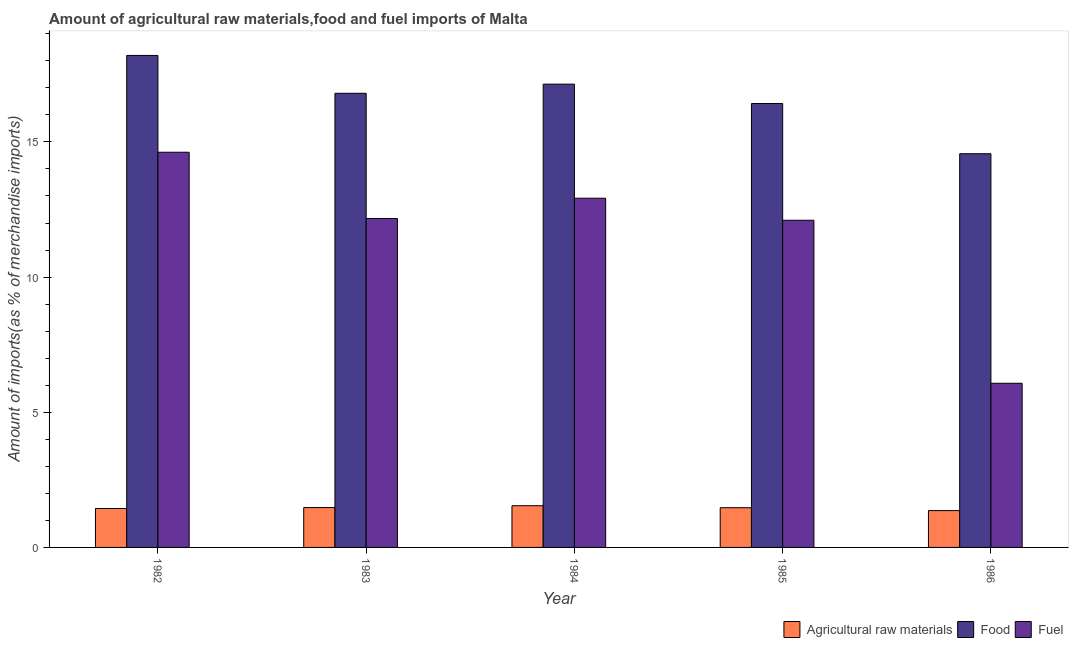Are the number of bars per tick equal to the number of legend labels?
Keep it short and to the point. Yes. Are the number of bars on each tick of the X-axis equal?
Offer a terse response. Yes. How many bars are there on the 4th tick from the left?
Make the answer very short. 3. What is the percentage of raw materials imports in 1985?
Provide a succinct answer. 1.47. Across all years, what is the maximum percentage of fuel imports?
Provide a succinct answer. 14.62. Across all years, what is the minimum percentage of fuel imports?
Provide a short and direct response. 6.07. In which year was the percentage of fuel imports maximum?
Offer a very short reply. 1982. What is the total percentage of fuel imports in the graph?
Your response must be concise. 57.88. What is the difference between the percentage of fuel imports in 1983 and that in 1985?
Provide a short and direct response. 0.07. What is the difference between the percentage of food imports in 1983 and the percentage of fuel imports in 1984?
Keep it short and to the point. -0.34. What is the average percentage of raw materials imports per year?
Keep it short and to the point. 1.46. In how many years, is the percentage of fuel imports greater than 4 %?
Make the answer very short. 5. What is the ratio of the percentage of fuel imports in 1983 to that in 1984?
Provide a succinct answer. 0.94. Is the difference between the percentage of raw materials imports in 1982 and 1984 greater than the difference between the percentage of food imports in 1982 and 1984?
Your answer should be very brief. No. What is the difference between the highest and the second highest percentage of raw materials imports?
Give a very brief answer. 0.07. What is the difference between the highest and the lowest percentage of raw materials imports?
Ensure brevity in your answer.  0.18. In how many years, is the percentage of food imports greater than the average percentage of food imports taken over all years?
Your answer should be very brief. 3. Is the sum of the percentage of raw materials imports in 1984 and 1986 greater than the maximum percentage of food imports across all years?
Provide a short and direct response. Yes. What does the 2nd bar from the left in 1982 represents?
Offer a very short reply. Food. What does the 1st bar from the right in 1985 represents?
Ensure brevity in your answer.  Fuel. How many bars are there?
Keep it short and to the point. 15. How many years are there in the graph?
Provide a succinct answer. 5. Does the graph contain grids?
Your response must be concise. No. How many legend labels are there?
Make the answer very short. 3. What is the title of the graph?
Make the answer very short. Amount of agricultural raw materials,food and fuel imports of Malta. What is the label or title of the X-axis?
Your answer should be very brief. Year. What is the label or title of the Y-axis?
Offer a very short reply. Amount of imports(as % of merchandise imports). What is the Amount of imports(as % of merchandise imports) in Agricultural raw materials in 1982?
Provide a succinct answer. 1.44. What is the Amount of imports(as % of merchandise imports) in Food in 1982?
Offer a terse response. 18.2. What is the Amount of imports(as % of merchandise imports) in Fuel in 1982?
Your answer should be compact. 14.62. What is the Amount of imports(as % of merchandise imports) of Agricultural raw materials in 1983?
Provide a short and direct response. 1.48. What is the Amount of imports(as % of merchandise imports) of Food in 1983?
Keep it short and to the point. 16.8. What is the Amount of imports(as % of merchandise imports) in Fuel in 1983?
Your answer should be very brief. 12.17. What is the Amount of imports(as % of merchandise imports) of Agricultural raw materials in 1984?
Give a very brief answer. 1.54. What is the Amount of imports(as % of merchandise imports) in Food in 1984?
Your answer should be very brief. 17.14. What is the Amount of imports(as % of merchandise imports) in Fuel in 1984?
Ensure brevity in your answer.  12.92. What is the Amount of imports(as % of merchandise imports) of Agricultural raw materials in 1985?
Give a very brief answer. 1.47. What is the Amount of imports(as % of merchandise imports) in Food in 1985?
Provide a succinct answer. 16.42. What is the Amount of imports(as % of merchandise imports) in Fuel in 1985?
Offer a terse response. 12.1. What is the Amount of imports(as % of merchandise imports) of Agricultural raw materials in 1986?
Give a very brief answer. 1.36. What is the Amount of imports(as % of merchandise imports) of Food in 1986?
Give a very brief answer. 14.56. What is the Amount of imports(as % of merchandise imports) of Fuel in 1986?
Make the answer very short. 6.07. Across all years, what is the maximum Amount of imports(as % of merchandise imports) in Agricultural raw materials?
Make the answer very short. 1.54. Across all years, what is the maximum Amount of imports(as % of merchandise imports) of Food?
Offer a terse response. 18.2. Across all years, what is the maximum Amount of imports(as % of merchandise imports) of Fuel?
Keep it short and to the point. 14.62. Across all years, what is the minimum Amount of imports(as % of merchandise imports) in Agricultural raw materials?
Offer a very short reply. 1.36. Across all years, what is the minimum Amount of imports(as % of merchandise imports) of Food?
Provide a succinct answer. 14.56. Across all years, what is the minimum Amount of imports(as % of merchandise imports) in Fuel?
Give a very brief answer. 6.07. What is the total Amount of imports(as % of merchandise imports) in Agricultural raw materials in the graph?
Keep it short and to the point. 7.29. What is the total Amount of imports(as % of merchandise imports) of Food in the graph?
Your answer should be very brief. 83.12. What is the total Amount of imports(as % of merchandise imports) of Fuel in the graph?
Provide a short and direct response. 57.88. What is the difference between the Amount of imports(as % of merchandise imports) in Agricultural raw materials in 1982 and that in 1983?
Provide a succinct answer. -0.03. What is the difference between the Amount of imports(as % of merchandise imports) of Food in 1982 and that in 1983?
Provide a short and direct response. 1.4. What is the difference between the Amount of imports(as % of merchandise imports) in Fuel in 1982 and that in 1983?
Your response must be concise. 2.45. What is the difference between the Amount of imports(as % of merchandise imports) in Agricultural raw materials in 1982 and that in 1984?
Your answer should be compact. -0.1. What is the difference between the Amount of imports(as % of merchandise imports) of Food in 1982 and that in 1984?
Offer a very short reply. 1.06. What is the difference between the Amount of imports(as % of merchandise imports) of Fuel in 1982 and that in 1984?
Offer a terse response. 1.7. What is the difference between the Amount of imports(as % of merchandise imports) of Agricultural raw materials in 1982 and that in 1985?
Provide a succinct answer. -0.03. What is the difference between the Amount of imports(as % of merchandise imports) of Food in 1982 and that in 1985?
Keep it short and to the point. 1.78. What is the difference between the Amount of imports(as % of merchandise imports) of Fuel in 1982 and that in 1985?
Your answer should be compact. 2.52. What is the difference between the Amount of imports(as % of merchandise imports) of Agricultural raw materials in 1982 and that in 1986?
Your answer should be very brief. 0.08. What is the difference between the Amount of imports(as % of merchandise imports) in Food in 1982 and that in 1986?
Give a very brief answer. 3.64. What is the difference between the Amount of imports(as % of merchandise imports) in Fuel in 1982 and that in 1986?
Ensure brevity in your answer.  8.55. What is the difference between the Amount of imports(as % of merchandise imports) of Agricultural raw materials in 1983 and that in 1984?
Your answer should be compact. -0.07. What is the difference between the Amount of imports(as % of merchandise imports) in Food in 1983 and that in 1984?
Offer a very short reply. -0.34. What is the difference between the Amount of imports(as % of merchandise imports) of Fuel in 1983 and that in 1984?
Your answer should be very brief. -0.75. What is the difference between the Amount of imports(as % of merchandise imports) of Agricultural raw materials in 1983 and that in 1985?
Offer a terse response. 0.01. What is the difference between the Amount of imports(as % of merchandise imports) of Food in 1983 and that in 1985?
Offer a very short reply. 0.38. What is the difference between the Amount of imports(as % of merchandise imports) of Fuel in 1983 and that in 1985?
Keep it short and to the point. 0.07. What is the difference between the Amount of imports(as % of merchandise imports) of Agricultural raw materials in 1983 and that in 1986?
Your answer should be compact. 0.11. What is the difference between the Amount of imports(as % of merchandise imports) of Food in 1983 and that in 1986?
Give a very brief answer. 2.24. What is the difference between the Amount of imports(as % of merchandise imports) of Fuel in 1983 and that in 1986?
Your answer should be very brief. 6.1. What is the difference between the Amount of imports(as % of merchandise imports) of Agricultural raw materials in 1984 and that in 1985?
Ensure brevity in your answer.  0.07. What is the difference between the Amount of imports(as % of merchandise imports) of Food in 1984 and that in 1985?
Offer a very short reply. 0.72. What is the difference between the Amount of imports(as % of merchandise imports) of Fuel in 1984 and that in 1985?
Provide a succinct answer. 0.82. What is the difference between the Amount of imports(as % of merchandise imports) of Agricultural raw materials in 1984 and that in 1986?
Keep it short and to the point. 0.18. What is the difference between the Amount of imports(as % of merchandise imports) of Food in 1984 and that in 1986?
Offer a very short reply. 2.57. What is the difference between the Amount of imports(as % of merchandise imports) in Fuel in 1984 and that in 1986?
Provide a short and direct response. 6.85. What is the difference between the Amount of imports(as % of merchandise imports) in Agricultural raw materials in 1985 and that in 1986?
Your response must be concise. 0.11. What is the difference between the Amount of imports(as % of merchandise imports) of Food in 1985 and that in 1986?
Offer a very short reply. 1.86. What is the difference between the Amount of imports(as % of merchandise imports) in Fuel in 1985 and that in 1986?
Give a very brief answer. 6.03. What is the difference between the Amount of imports(as % of merchandise imports) of Agricultural raw materials in 1982 and the Amount of imports(as % of merchandise imports) of Food in 1983?
Your answer should be compact. -15.36. What is the difference between the Amount of imports(as % of merchandise imports) in Agricultural raw materials in 1982 and the Amount of imports(as % of merchandise imports) in Fuel in 1983?
Your answer should be very brief. -10.73. What is the difference between the Amount of imports(as % of merchandise imports) in Food in 1982 and the Amount of imports(as % of merchandise imports) in Fuel in 1983?
Your response must be concise. 6.03. What is the difference between the Amount of imports(as % of merchandise imports) in Agricultural raw materials in 1982 and the Amount of imports(as % of merchandise imports) in Food in 1984?
Your response must be concise. -15.7. What is the difference between the Amount of imports(as % of merchandise imports) of Agricultural raw materials in 1982 and the Amount of imports(as % of merchandise imports) of Fuel in 1984?
Your answer should be very brief. -11.48. What is the difference between the Amount of imports(as % of merchandise imports) of Food in 1982 and the Amount of imports(as % of merchandise imports) of Fuel in 1984?
Make the answer very short. 5.28. What is the difference between the Amount of imports(as % of merchandise imports) in Agricultural raw materials in 1982 and the Amount of imports(as % of merchandise imports) in Food in 1985?
Keep it short and to the point. -14.98. What is the difference between the Amount of imports(as % of merchandise imports) of Agricultural raw materials in 1982 and the Amount of imports(as % of merchandise imports) of Fuel in 1985?
Provide a succinct answer. -10.66. What is the difference between the Amount of imports(as % of merchandise imports) of Food in 1982 and the Amount of imports(as % of merchandise imports) of Fuel in 1985?
Make the answer very short. 6.1. What is the difference between the Amount of imports(as % of merchandise imports) of Agricultural raw materials in 1982 and the Amount of imports(as % of merchandise imports) of Food in 1986?
Your answer should be very brief. -13.12. What is the difference between the Amount of imports(as % of merchandise imports) in Agricultural raw materials in 1982 and the Amount of imports(as % of merchandise imports) in Fuel in 1986?
Give a very brief answer. -4.63. What is the difference between the Amount of imports(as % of merchandise imports) of Food in 1982 and the Amount of imports(as % of merchandise imports) of Fuel in 1986?
Ensure brevity in your answer.  12.13. What is the difference between the Amount of imports(as % of merchandise imports) of Agricultural raw materials in 1983 and the Amount of imports(as % of merchandise imports) of Food in 1984?
Provide a succinct answer. -15.66. What is the difference between the Amount of imports(as % of merchandise imports) of Agricultural raw materials in 1983 and the Amount of imports(as % of merchandise imports) of Fuel in 1984?
Offer a terse response. -11.44. What is the difference between the Amount of imports(as % of merchandise imports) of Food in 1983 and the Amount of imports(as % of merchandise imports) of Fuel in 1984?
Make the answer very short. 3.88. What is the difference between the Amount of imports(as % of merchandise imports) of Agricultural raw materials in 1983 and the Amount of imports(as % of merchandise imports) of Food in 1985?
Offer a terse response. -14.95. What is the difference between the Amount of imports(as % of merchandise imports) in Agricultural raw materials in 1983 and the Amount of imports(as % of merchandise imports) in Fuel in 1985?
Offer a terse response. -10.63. What is the difference between the Amount of imports(as % of merchandise imports) in Food in 1983 and the Amount of imports(as % of merchandise imports) in Fuel in 1985?
Offer a terse response. 4.7. What is the difference between the Amount of imports(as % of merchandise imports) in Agricultural raw materials in 1983 and the Amount of imports(as % of merchandise imports) in Food in 1986?
Offer a very short reply. -13.09. What is the difference between the Amount of imports(as % of merchandise imports) in Agricultural raw materials in 1983 and the Amount of imports(as % of merchandise imports) in Fuel in 1986?
Ensure brevity in your answer.  -4.6. What is the difference between the Amount of imports(as % of merchandise imports) of Food in 1983 and the Amount of imports(as % of merchandise imports) of Fuel in 1986?
Provide a short and direct response. 10.73. What is the difference between the Amount of imports(as % of merchandise imports) of Agricultural raw materials in 1984 and the Amount of imports(as % of merchandise imports) of Food in 1985?
Your answer should be compact. -14.88. What is the difference between the Amount of imports(as % of merchandise imports) in Agricultural raw materials in 1984 and the Amount of imports(as % of merchandise imports) in Fuel in 1985?
Ensure brevity in your answer.  -10.56. What is the difference between the Amount of imports(as % of merchandise imports) in Food in 1984 and the Amount of imports(as % of merchandise imports) in Fuel in 1985?
Offer a very short reply. 5.03. What is the difference between the Amount of imports(as % of merchandise imports) of Agricultural raw materials in 1984 and the Amount of imports(as % of merchandise imports) of Food in 1986?
Your answer should be very brief. -13.02. What is the difference between the Amount of imports(as % of merchandise imports) in Agricultural raw materials in 1984 and the Amount of imports(as % of merchandise imports) in Fuel in 1986?
Your answer should be very brief. -4.53. What is the difference between the Amount of imports(as % of merchandise imports) of Food in 1984 and the Amount of imports(as % of merchandise imports) of Fuel in 1986?
Your answer should be compact. 11.06. What is the difference between the Amount of imports(as % of merchandise imports) in Agricultural raw materials in 1985 and the Amount of imports(as % of merchandise imports) in Food in 1986?
Your response must be concise. -13.09. What is the difference between the Amount of imports(as % of merchandise imports) in Agricultural raw materials in 1985 and the Amount of imports(as % of merchandise imports) in Fuel in 1986?
Provide a succinct answer. -4.6. What is the difference between the Amount of imports(as % of merchandise imports) in Food in 1985 and the Amount of imports(as % of merchandise imports) in Fuel in 1986?
Keep it short and to the point. 10.35. What is the average Amount of imports(as % of merchandise imports) in Agricultural raw materials per year?
Ensure brevity in your answer.  1.46. What is the average Amount of imports(as % of merchandise imports) in Food per year?
Provide a short and direct response. 16.62. What is the average Amount of imports(as % of merchandise imports) in Fuel per year?
Provide a short and direct response. 11.58. In the year 1982, what is the difference between the Amount of imports(as % of merchandise imports) of Agricultural raw materials and Amount of imports(as % of merchandise imports) of Food?
Give a very brief answer. -16.76. In the year 1982, what is the difference between the Amount of imports(as % of merchandise imports) in Agricultural raw materials and Amount of imports(as % of merchandise imports) in Fuel?
Your response must be concise. -13.18. In the year 1982, what is the difference between the Amount of imports(as % of merchandise imports) of Food and Amount of imports(as % of merchandise imports) of Fuel?
Your answer should be very brief. 3.58. In the year 1983, what is the difference between the Amount of imports(as % of merchandise imports) in Agricultural raw materials and Amount of imports(as % of merchandise imports) in Food?
Keep it short and to the point. -15.32. In the year 1983, what is the difference between the Amount of imports(as % of merchandise imports) in Agricultural raw materials and Amount of imports(as % of merchandise imports) in Fuel?
Your answer should be very brief. -10.69. In the year 1983, what is the difference between the Amount of imports(as % of merchandise imports) in Food and Amount of imports(as % of merchandise imports) in Fuel?
Ensure brevity in your answer.  4.63. In the year 1984, what is the difference between the Amount of imports(as % of merchandise imports) in Agricultural raw materials and Amount of imports(as % of merchandise imports) in Food?
Keep it short and to the point. -15.59. In the year 1984, what is the difference between the Amount of imports(as % of merchandise imports) of Agricultural raw materials and Amount of imports(as % of merchandise imports) of Fuel?
Your answer should be very brief. -11.37. In the year 1984, what is the difference between the Amount of imports(as % of merchandise imports) of Food and Amount of imports(as % of merchandise imports) of Fuel?
Give a very brief answer. 4.22. In the year 1985, what is the difference between the Amount of imports(as % of merchandise imports) in Agricultural raw materials and Amount of imports(as % of merchandise imports) in Food?
Keep it short and to the point. -14.95. In the year 1985, what is the difference between the Amount of imports(as % of merchandise imports) in Agricultural raw materials and Amount of imports(as % of merchandise imports) in Fuel?
Ensure brevity in your answer.  -10.63. In the year 1985, what is the difference between the Amount of imports(as % of merchandise imports) in Food and Amount of imports(as % of merchandise imports) in Fuel?
Your response must be concise. 4.32. In the year 1986, what is the difference between the Amount of imports(as % of merchandise imports) of Agricultural raw materials and Amount of imports(as % of merchandise imports) of Food?
Provide a succinct answer. -13.2. In the year 1986, what is the difference between the Amount of imports(as % of merchandise imports) in Agricultural raw materials and Amount of imports(as % of merchandise imports) in Fuel?
Offer a terse response. -4.71. In the year 1986, what is the difference between the Amount of imports(as % of merchandise imports) in Food and Amount of imports(as % of merchandise imports) in Fuel?
Your answer should be compact. 8.49. What is the ratio of the Amount of imports(as % of merchandise imports) of Agricultural raw materials in 1982 to that in 1983?
Your response must be concise. 0.98. What is the ratio of the Amount of imports(as % of merchandise imports) of Food in 1982 to that in 1983?
Make the answer very short. 1.08. What is the ratio of the Amount of imports(as % of merchandise imports) of Fuel in 1982 to that in 1983?
Make the answer very short. 1.2. What is the ratio of the Amount of imports(as % of merchandise imports) in Agricultural raw materials in 1982 to that in 1984?
Make the answer very short. 0.93. What is the ratio of the Amount of imports(as % of merchandise imports) of Food in 1982 to that in 1984?
Provide a short and direct response. 1.06. What is the ratio of the Amount of imports(as % of merchandise imports) in Fuel in 1982 to that in 1984?
Provide a short and direct response. 1.13. What is the ratio of the Amount of imports(as % of merchandise imports) in Agricultural raw materials in 1982 to that in 1985?
Provide a succinct answer. 0.98. What is the ratio of the Amount of imports(as % of merchandise imports) in Food in 1982 to that in 1985?
Your answer should be very brief. 1.11. What is the ratio of the Amount of imports(as % of merchandise imports) of Fuel in 1982 to that in 1985?
Give a very brief answer. 1.21. What is the ratio of the Amount of imports(as % of merchandise imports) of Agricultural raw materials in 1982 to that in 1986?
Keep it short and to the point. 1.06. What is the ratio of the Amount of imports(as % of merchandise imports) in Food in 1982 to that in 1986?
Your answer should be compact. 1.25. What is the ratio of the Amount of imports(as % of merchandise imports) in Fuel in 1982 to that in 1986?
Offer a very short reply. 2.41. What is the ratio of the Amount of imports(as % of merchandise imports) of Agricultural raw materials in 1983 to that in 1984?
Your response must be concise. 0.96. What is the ratio of the Amount of imports(as % of merchandise imports) of Food in 1983 to that in 1984?
Make the answer very short. 0.98. What is the ratio of the Amount of imports(as % of merchandise imports) in Fuel in 1983 to that in 1984?
Make the answer very short. 0.94. What is the ratio of the Amount of imports(as % of merchandise imports) of Fuel in 1983 to that in 1985?
Keep it short and to the point. 1.01. What is the ratio of the Amount of imports(as % of merchandise imports) in Agricultural raw materials in 1983 to that in 1986?
Provide a short and direct response. 1.08. What is the ratio of the Amount of imports(as % of merchandise imports) of Food in 1983 to that in 1986?
Provide a succinct answer. 1.15. What is the ratio of the Amount of imports(as % of merchandise imports) in Fuel in 1983 to that in 1986?
Give a very brief answer. 2. What is the ratio of the Amount of imports(as % of merchandise imports) in Agricultural raw materials in 1984 to that in 1985?
Provide a succinct answer. 1.05. What is the ratio of the Amount of imports(as % of merchandise imports) in Food in 1984 to that in 1985?
Give a very brief answer. 1.04. What is the ratio of the Amount of imports(as % of merchandise imports) in Fuel in 1984 to that in 1985?
Give a very brief answer. 1.07. What is the ratio of the Amount of imports(as % of merchandise imports) of Agricultural raw materials in 1984 to that in 1986?
Give a very brief answer. 1.13. What is the ratio of the Amount of imports(as % of merchandise imports) in Food in 1984 to that in 1986?
Make the answer very short. 1.18. What is the ratio of the Amount of imports(as % of merchandise imports) in Fuel in 1984 to that in 1986?
Give a very brief answer. 2.13. What is the ratio of the Amount of imports(as % of merchandise imports) of Agricultural raw materials in 1985 to that in 1986?
Keep it short and to the point. 1.08. What is the ratio of the Amount of imports(as % of merchandise imports) of Food in 1985 to that in 1986?
Offer a very short reply. 1.13. What is the ratio of the Amount of imports(as % of merchandise imports) of Fuel in 1985 to that in 1986?
Give a very brief answer. 1.99. What is the difference between the highest and the second highest Amount of imports(as % of merchandise imports) in Agricultural raw materials?
Your answer should be compact. 0.07. What is the difference between the highest and the second highest Amount of imports(as % of merchandise imports) of Food?
Provide a succinct answer. 1.06. What is the difference between the highest and the second highest Amount of imports(as % of merchandise imports) in Fuel?
Offer a terse response. 1.7. What is the difference between the highest and the lowest Amount of imports(as % of merchandise imports) in Agricultural raw materials?
Offer a terse response. 0.18. What is the difference between the highest and the lowest Amount of imports(as % of merchandise imports) in Food?
Your answer should be very brief. 3.64. What is the difference between the highest and the lowest Amount of imports(as % of merchandise imports) in Fuel?
Provide a short and direct response. 8.55. 